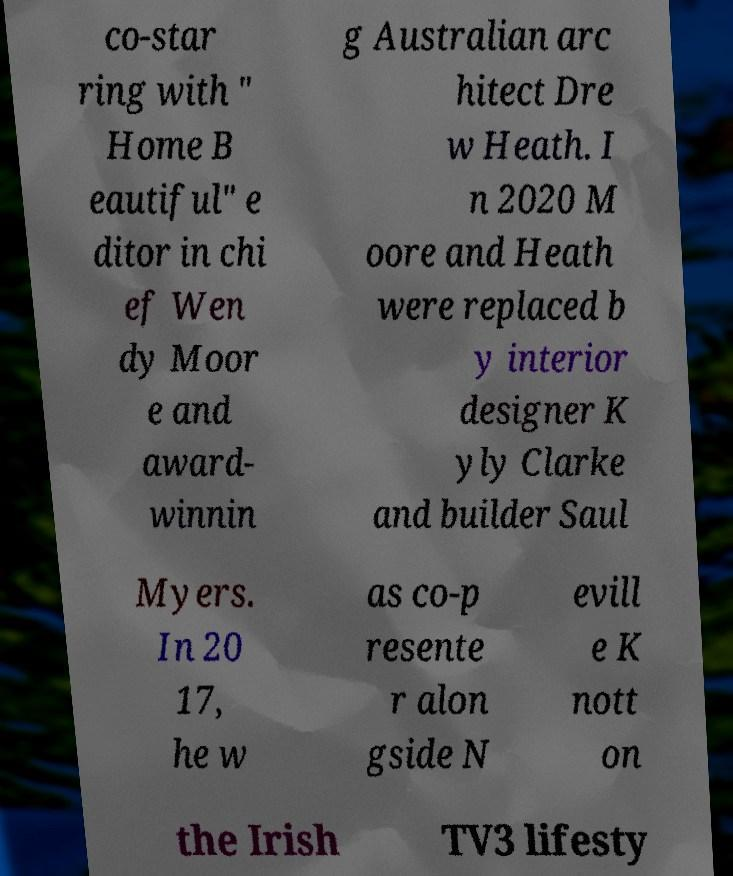Can you accurately transcribe the text from the provided image for me? co-star ring with " Home B eautiful" e ditor in chi ef Wen dy Moor e and award- winnin g Australian arc hitect Dre w Heath. I n 2020 M oore and Heath were replaced b y interior designer K yly Clarke and builder Saul Myers. In 20 17, he w as co-p resente r alon gside N evill e K nott on the Irish TV3 lifesty 